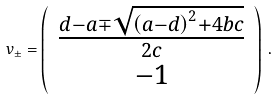<formula> <loc_0><loc_0><loc_500><loc_500>v _ { \pm } = \left ( \begin{array} { c } \frac { d - a \mp \sqrt { \left ( a - d \right ) ^ { 2 } + 4 b c } } { 2 c } \\ - 1 \end{array} \right ) \, .</formula> 